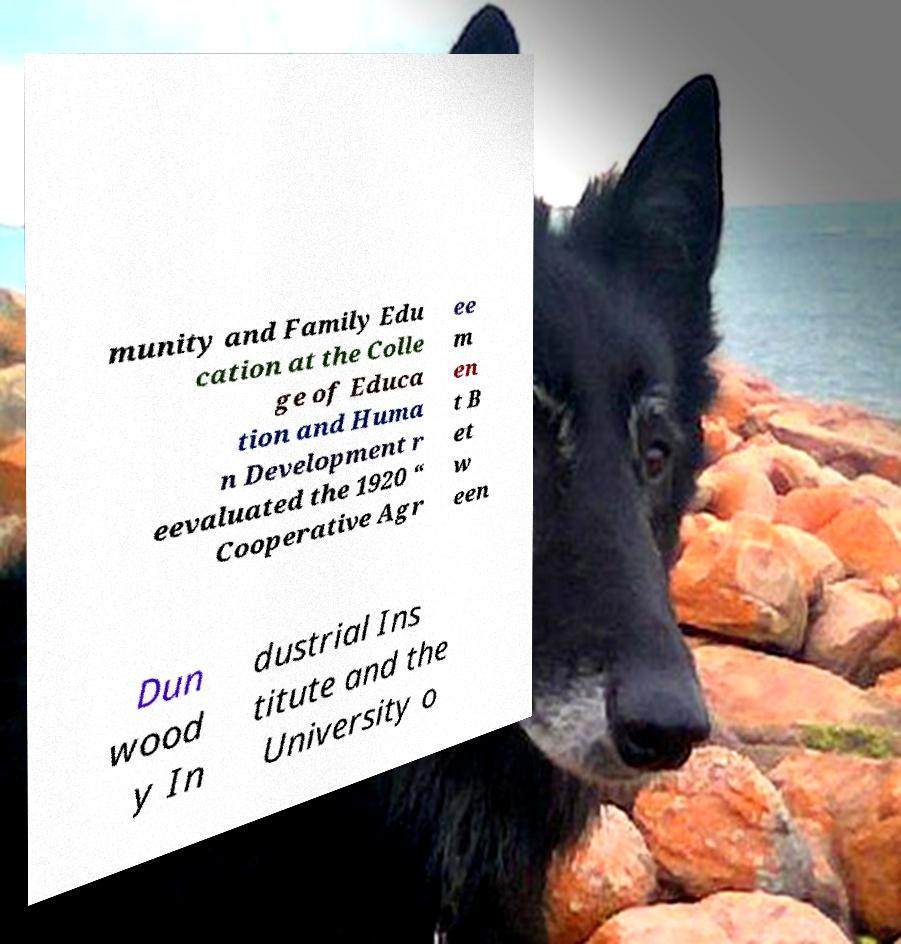There's text embedded in this image that I need extracted. Can you transcribe it verbatim? munity and Family Edu cation at the Colle ge of Educa tion and Huma n Development r eevaluated the 1920 “ Cooperative Agr ee m en t B et w een Dun wood y In dustrial Ins titute and the University o 